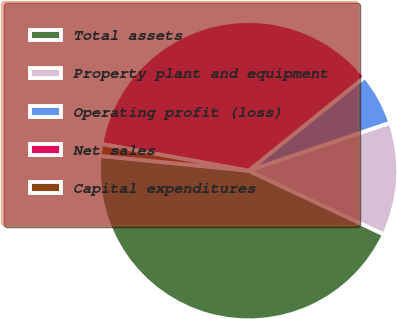Convert chart. <chart><loc_0><loc_0><loc_500><loc_500><pie_chart><fcel>Total assets<fcel>Property plant and equipment<fcel>Operating profit (loss)<fcel>Net sales<fcel>Capital expenditures<nl><fcel>44.57%<fcel>12.21%<fcel>5.6%<fcel>36.34%<fcel>1.27%<nl></chart> 